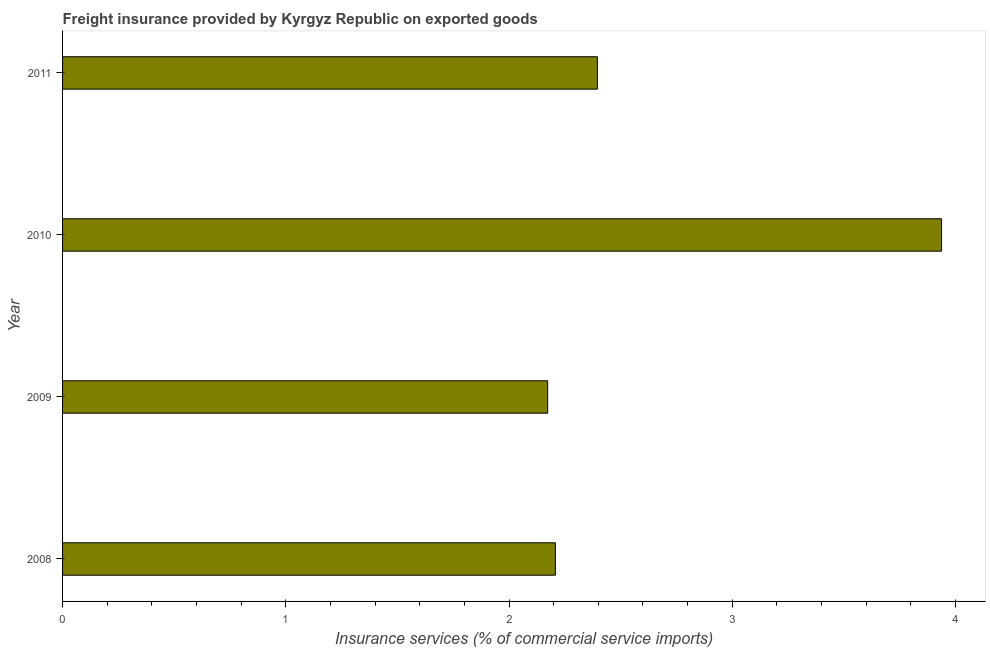Does the graph contain grids?
Provide a succinct answer. No. What is the title of the graph?
Your response must be concise. Freight insurance provided by Kyrgyz Republic on exported goods . What is the label or title of the X-axis?
Your response must be concise. Insurance services (% of commercial service imports). What is the freight insurance in 2009?
Your answer should be very brief. 2.17. Across all years, what is the maximum freight insurance?
Ensure brevity in your answer.  3.94. Across all years, what is the minimum freight insurance?
Your answer should be compact. 2.17. In which year was the freight insurance maximum?
Make the answer very short. 2010. In which year was the freight insurance minimum?
Provide a short and direct response. 2009. What is the sum of the freight insurance?
Your answer should be very brief. 10.71. What is the difference between the freight insurance in 2010 and 2011?
Provide a succinct answer. 1.54. What is the average freight insurance per year?
Your response must be concise. 2.68. What is the median freight insurance?
Ensure brevity in your answer.  2.3. In how many years, is the freight insurance greater than 3 %?
Keep it short and to the point. 1. Do a majority of the years between 2011 and 2010 (inclusive) have freight insurance greater than 3.6 %?
Make the answer very short. No. What is the ratio of the freight insurance in 2009 to that in 2011?
Make the answer very short. 0.91. Is the freight insurance in 2009 less than that in 2010?
Offer a terse response. Yes. What is the difference between the highest and the second highest freight insurance?
Offer a terse response. 1.54. Is the sum of the freight insurance in 2008 and 2009 greater than the maximum freight insurance across all years?
Give a very brief answer. Yes. What is the difference between the highest and the lowest freight insurance?
Offer a terse response. 1.76. Are all the bars in the graph horizontal?
Provide a succinct answer. Yes. What is the difference between two consecutive major ticks on the X-axis?
Keep it short and to the point. 1. What is the Insurance services (% of commercial service imports) of 2008?
Provide a short and direct response. 2.21. What is the Insurance services (% of commercial service imports) in 2009?
Make the answer very short. 2.17. What is the Insurance services (% of commercial service imports) in 2010?
Your response must be concise. 3.94. What is the Insurance services (% of commercial service imports) of 2011?
Your answer should be compact. 2.4. What is the difference between the Insurance services (% of commercial service imports) in 2008 and 2009?
Offer a very short reply. 0.03. What is the difference between the Insurance services (% of commercial service imports) in 2008 and 2010?
Offer a very short reply. -1.73. What is the difference between the Insurance services (% of commercial service imports) in 2008 and 2011?
Provide a succinct answer. -0.19. What is the difference between the Insurance services (% of commercial service imports) in 2009 and 2010?
Keep it short and to the point. -1.76. What is the difference between the Insurance services (% of commercial service imports) in 2009 and 2011?
Your answer should be compact. -0.22. What is the difference between the Insurance services (% of commercial service imports) in 2010 and 2011?
Your answer should be very brief. 1.54. What is the ratio of the Insurance services (% of commercial service imports) in 2008 to that in 2009?
Give a very brief answer. 1.02. What is the ratio of the Insurance services (% of commercial service imports) in 2008 to that in 2010?
Your answer should be compact. 0.56. What is the ratio of the Insurance services (% of commercial service imports) in 2008 to that in 2011?
Offer a very short reply. 0.92. What is the ratio of the Insurance services (% of commercial service imports) in 2009 to that in 2010?
Make the answer very short. 0.55. What is the ratio of the Insurance services (% of commercial service imports) in 2009 to that in 2011?
Provide a short and direct response. 0.91. What is the ratio of the Insurance services (% of commercial service imports) in 2010 to that in 2011?
Your answer should be very brief. 1.64. 